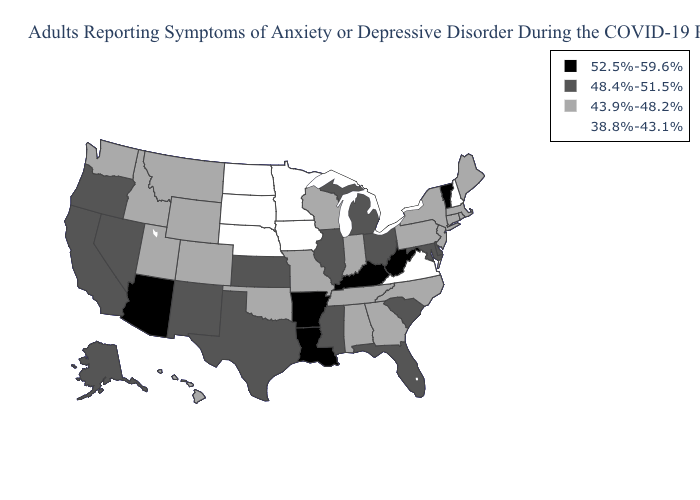What is the value of Georgia?
Answer briefly. 43.9%-48.2%. Does the map have missing data?
Answer briefly. No. Name the states that have a value in the range 48.4%-51.5%?
Concise answer only. Alaska, California, Delaware, Florida, Illinois, Kansas, Maryland, Michigan, Mississippi, Nevada, New Mexico, Ohio, Oregon, South Carolina, Texas. Name the states that have a value in the range 52.5%-59.6%?
Answer briefly. Arizona, Arkansas, Kentucky, Louisiana, Vermont, West Virginia. Name the states that have a value in the range 43.9%-48.2%?
Short answer required. Alabama, Colorado, Connecticut, Georgia, Hawaii, Idaho, Indiana, Maine, Massachusetts, Missouri, Montana, New Jersey, New York, North Carolina, Oklahoma, Pennsylvania, Rhode Island, Tennessee, Utah, Washington, Wisconsin, Wyoming. What is the value of Delaware?
Write a very short answer. 48.4%-51.5%. Does the map have missing data?
Give a very brief answer. No. Which states have the lowest value in the MidWest?
Answer briefly. Iowa, Minnesota, Nebraska, North Dakota, South Dakota. What is the highest value in states that border Tennessee?
Short answer required. 52.5%-59.6%. Name the states that have a value in the range 48.4%-51.5%?
Short answer required. Alaska, California, Delaware, Florida, Illinois, Kansas, Maryland, Michigan, Mississippi, Nevada, New Mexico, Ohio, Oregon, South Carolina, Texas. Which states have the highest value in the USA?
Keep it brief. Arizona, Arkansas, Kentucky, Louisiana, Vermont, West Virginia. Name the states that have a value in the range 38.8%-43.1%?
Answer briefly. Iowa, Minnesota, Nebraska, New Hampshire, North Dakota, South Dakota, Virginia. What is the lowest value in the USA?
Short answer required. 38.8%-43.1%. Which states have the lowest value in the West?
Write a very short answer. Colorado, Hawaii, Idaho, Montana, Utah, Washington, Wyoming. 